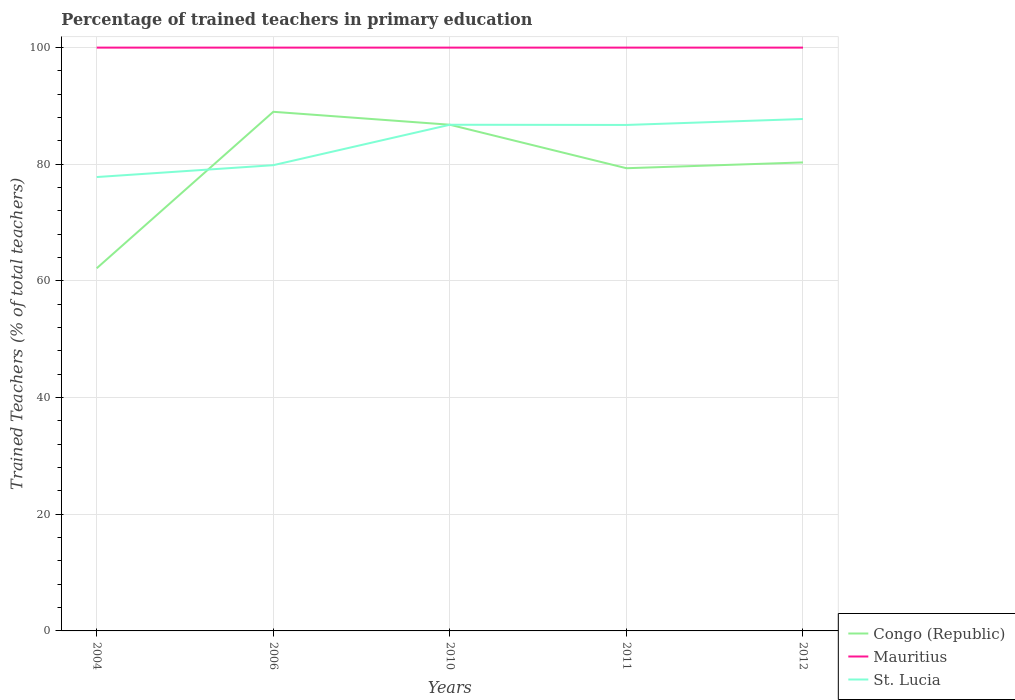How many different coloured lines are there?
Your response must be concise. 3. Does the line corresponding to St. Lucia intersect with the line corresponding to Congo (Republic)?
Keep it short and to the point. Yes. Is the number of lines equal to the number of legend labels?
Provide a succinct answer. Yes. Across all years, what is the maximum percentage of trained teachers in St. Lucia?
Provide a succinct answer. 77.81. What is the total percentage of trained teachers in Congo (Republic) in the graph?
Your answer should be very brief. -17.15. What is the difference between the highest and the second highest percentage of trained teachers in St. Lucia?
Make the answer very short. 9.95. How many lines are there?
Your answer should be compact. 3. How many years are there in the graph?
Provide a short and direct response. 5. What is the difference between two consecutive major ticks on the Y-axis?
Make the answer very short. 20. Does the graph contain any zero values?
Ensure brevity in your answer.  No. Where does the legend appear in the graph?
Make the answer very short. Bottom right. How many legend labels are there?
Your response must be concise. 3. How are the legend labels stacked?
Keep it short and to the point. Vertical. What is the title of the graph?
Provide a short and direct response. Percentage of trained teachers in primary education. What is the label or title of the X-axis?
Make the answer very short. Years. What is the label or title of the Y-axis?
Keep it short and to the point. Trained Teachers (% of total teachers). What is the Trained Teachers (% of total teachers) of Congo (Republic) in 2004?
Offer a terse response. 62.17. What is the Trained Teachers (% of total teachers) of St. Lucia in 2004?
Provide a succinct answer. 77.81. What is the Trained Teachers (% of total teachers) of Congo (Republic) in 2006?
Keep it short and to the point. 89. What is the Trained Teachers (% of total teachers) of St. Lucia in 2006?
Offer a terse response. 79.84. What is the Trained Teachers (% of total teachers) of Congo (Republic) in 2010?
Your response must be concise. 86.78. What is the Trained Teachers (% of total teachers) of St. Lucia in 2010?
Your response must be concise. 86.77. What is the Trained Teachers (% of total teachers) of Congo (Republic) in 2011?
Your answer should be very brief. 79.32. What is the Trained Teachers (% of total teachers) of St. Lucia in 2011?
Make the answer very short. 86.74. What is the Trained Teachers (% of total teachers) in Congo (Republic) in 2012?
Your answer should be very brief. 80.32. What is the Trained Teachers (% of total teachers) of Mauritius in 2012?
Provide a short and direct response. 100. What is the Trained Teachers (% of total teachers) in St. Lucia in 2012?
Give a very brief answer. 87.76. Across all years, what is the maximum Trained Teachers (% of total teachers) of Congo (Republic)?
Offer a terse response. 89. Across all years, what is the maximum Trained Teachers (% of total teachers) of Mauritius?
Provide a succinct answer. 100. Across all years, what is the maximum Trained Teachers (% of total teachers) of St. Lucia?
Your answer should be compact. 87.76. Across all years, what is the minimum Trained Teachers (% of total teachers) of Congo (Republic)?
Ensure brevity in your answer.  62.17. Across all years, what is the minimum Trained Teachers (% of total teachers) of Mauritius?
Your answer should be very brief. 100. Across all years, what is the minimum Trained Teachers (% of total teachers) of St. Lucia?
Provide a succinct answer. 77.81. What is the total Trained Teachers (% of total teachers) in Congo (Republic) in the graph?
Make the answer very short. 397.59. What is the total Trained Teachers (% of total teachers) of St. Lucia in the graph?
Offer a very short reply. 418.93. What is the difference between the Trained Teachers (% of total teachers) of Congo (Republic) in 2004 and that in 2006?
Provide a succinct answer. -26.83. What is the difference between the Trained Teachers (% of total teachers) of St. Lucia in 2004 and that in 2006?
Ensure brevity in your answer.  -2.03. What is the difference between the Trained Teachers (% of total teachers) of Congo (Republic) in 2004 and that in 2010?
Ensure brevity in your answer.  -24.61. What is the difference between the Trained Teachers (% of total teachers) in Mauritius in 2004 and that in 2010?
Ensure brevity in your answer.  0. What is the difference between the Trained Teachers (% of total teachers) of St. Lucia in 2004 and that in 2010?
Your answer should be very brief. -8.96. What is the difference between the Trained Teachers (% of total teachers) in Congo (Republic) in 2004 and that in 2011?
Provide a short and direct response. -17.15. What is the difference between the Trained Teachers (% of total teachers) in St. Lucia in 2004 and that in 2011?
Provide a short and direct response. -8.93. What is the difference between the Trained Teachers (% of total teachers) in Congo (Republic) in 2004 and that in 2012?
Keep it short and to the point. -18.15. What is the difference between the Trained Teachers (% of total teachers) in Mauritius in 2004 and that in 2012?
Provide a succinct answer. 0. What is the difference between the Trained Teachers (% of total teachers) in St. Lucia in 2004 and that in 2012?
Offer a terse response. -9.95. What is the difference between the Trained Teachers (% of total teachers) of Congo (Republic) in 2006 and that in 2010?
Offer a very short reply. 2.22. What is the difference between the Trained Teachers (% of total teachers) of Mauritius in 2006 and that in 2010?
Keep it short and to the point. 0. What is the difference between the Trained Teachers (% of total teachers) of St. Lucia in 2006 and that in 2010?
Make the answer very short. -6.93. What is the difference between the Trained Teachers (% of total teachers) of Congo (Republic) in 2006 and that in 2011?
Provide a short and direct response. 9.67. What is the difference between the Trained Teachers (% of total teachers) in St. Lucia in 2006 and that in 2011?
Offer a very short reply. -6.9. What is the difference between the Trained Teachers (% of total teachers) in Congo (Republic) in 2006 and that in 2012?
Provide a succinct answer. 8.68. What is the difference between the Trained Teachers (% of total teachers) of Mauritius in 2006 and that in 2012?
Make the answer very short. 0. What is the difference between the Trained Teachers (% of total teachers) of St. Lucia in 2006 and that in 2012?
Provide a succinct answer. -7.92. What is the difference between the Trained Teachers (% of total teachers) in Congo (Republic) in 2010 and that in 2011?
Make the answer very short. 7.45. What is the difference between the Trained Teachers (% of total teachers) in Mauritius in 2010 and that in 2011?
Give a very brief answer. 0. What is the difference between the Trained Teachers (% of total teachers) in St. Lucia in 2010 and that in 2011?
Offer a terse response. 0.03. What is the difference between the Trained Teachers (% of total teachers) in Congo (Republic) in 2010 and that in 2012?
Provide a succinct answer. 6.46. What is the difference between the Trained Teachers (% of total teachers) in Mauritius in 2010 and that in 2012?
Provide a succinct answer. 0. What is the difference between the Trained Teachers (% of total teachers) of St. Lucia in 2010 and that in 2012?
Ensure brevity in your answer.  -0.99. What is the difference between the Trained Teachers (% of total teachers) of Congo (Republic) in 2011 and that in 2012?
Offer a terse response. -0.99. What is the difference between the Trained Teachers (% of total teachers) of St. Lucia in 2011 and that in 2012?
Make the answer very short. -1.02. What is the difference between the Trained Teachers (% of total teachers) in Congo (Republic) in 2004 and the Trained Teachers (% of total teachers) in Mauritius in 2006?
Your answer should be very brief. -37.83. What is the difference between the Trained Teachers (% of total teachers) of Congo (Republic) in 2004 and the Trained Teachers (% of total teachers) of St. Lucia in 2006?
Your response must be concise. -17.67. What is the difference between the Trained Teachers (% of total teachers) in Mauritius in 2004 and the Trained Teachers (% of total teachers) in St. Lucia in 2006?
Offer a very short reply. 20.16. What is the difference between the Trained Teachers (% of total teachers) in Congo (Republic) in 2004 and the Trained Teachers (% of total teachers) in Mauritius in 2010?
Keep it short and to the point. -37.83. What is the difference between the Trained Teachers (% of total teachers) of Congo (Republic) in 2004 and the Trained Teachers (% of total teachers) of St. Lucia in 2010?
Offer a terse response. -24.6. What is the difference between the Trained Teachers (% of total teachers) in Mauritius in 2004 and the Trained Teachers (% of total teachers) in St. Lucia in 2010?
Ensure brevity in your answer.  13.23. What is the difference between the Trained Teachers (% of total teachers) of Congo (Republic) in 2004 and the Trained Teachers (% of total teachers) of Mauritius in 2011?
Keep it short and to the point. -37.83. What is the difference between the Trained Teachers (% of total teachers) in Congo (Republic) in 2004 and the Trained Teachers (% of total teachers) in St. Lucia in 2011?
Offer a terse response. -24.57. What is the difference between the Trained Teachers (% of total teachers) of Mauritius in 2004 and the Trained Teachers (% of total teachers) of St. Lucia in 2011?
Your response must be concise. 13.26. What is the difference between the Trained Teachers (% of total teachers) in Congo (Republic) in 2004 and the Trained Teachers (% of total teachers) in Mauritius in 2012?
Give a very brief answer. -37.83. What is the difference between the Trained Teachers (% of total teachers) of Congo (Republic) in 2004 and the Trained Teachers (% of total teachers) of St. Lucia in 2012?
Provide a succinct answer. -25.59. What is the difference between the Trained Teachers (% of total teachers) of Mauritius in 2004 and the Trained Teachers (% of total teachers) of St. Lucia in 2012?
Provide a succinct answer. 12.24. What is the difference between the Trained Teachers (% of total teachers) of Congo (Republic) in 2006 and the Trained Teachers (% of total teachers) of Mauritius in 2010?
Offer a very short reply. -11. What is the difference between the Trained Teachers (% of total teachers) in Congo (Republic) in 2006 and the Trained Teachers (% of total teachers) in St. Lucia in 2010?
Give a very brief answer. 2.22. What is the difference between the Trained Teachers (% of total teachers) of Mauritius in 2006 and the Trained Teachers (% of total teachers) of St. Lucia in 2010?
Provide a succinct answer. 13.23. What is the difference between the Trained Teachers (% of total teachers) in Congo (Republic) in 2006 and the Trained Teachers (% of total teachers) in Mauritius in 2011?
Your answer should be compact. -11. What is the difference between the Trained Teachers (% of total teachers) of Congo (Republic) in 2006 and the Trained Teachers (% of total teachers) of St. Lucia in 2011?
Make the answer very short. 2.26. What is the difference between the Trained Teachers (% of total teachers) of Mauritius in 2006 and the Trained Teachers (% of total teachers) of St. Lucia in 2011?
Make the answer very short. 13.26. What is the difference between the Trained Teachers (% of total teachers) of Congo (Republic) in 2006 and the Trained Teachers (% of total teachers) of Mauritius in 2012?
Make the answer very short. -11. What is the difference between the Trained Teachers (% of total teachers) in Congo (Republic) in 2006 and the Trained Teachers (% of total teachers) in St. Lucia in 2012?
Your response must be concise. 1.24. What is the difference between the Trained Teachers (% of total teachers) in Mauritius in 2006 and the Trained Teachers (% of total teachers) in St. Lucia in 2012?
Offer a very short reply. 12.24. What is the difference between the Trained Teachers (% of total teachers) of Congo (Republic) in 2010 and the Trained Teachers (% of total teachers) of Mauritius in 2011?
Ensure brevity in your answer.  -13.22. What is the difference between the Trained Teachers (% of total teachers) in Congo (Republic) in 2010 and the Trained Teachers (% of total teachers) in St. Lucia in 2011?
Give a very brief answer. 0.04. What is the difference between the Trained Teachers (% of total teachers) in Mauritius in 2010 and the Trained Teachers (% of total teachers) in St. Lucia in 2011?
Your answer should be compact. 13.26. What is the difference between the Trained Teachers (% of total teachers) in Congo (Republic) in 2010 and the Trained Teachers (% of total teachers) in Mauritius in 2012?
Offer a terse response. -13.22. What is the difference between the Trained Teachers (% of total teachers) in Congo (Republic) in 2010 and the Trained Teachers (% of total teachers) in St. Lucia in 2012?
Offer a terse response. -0.98. What is the difference between the Trained Teachers (% of total teachers) of Mauritius in 2010 and the Trained Teachers (% of total teachers) of St. Lucia in 2012?
Offer a terse response. 12.24. What is the difference between the Trained Teachers (% of total teachers) in Congo (Republic) in 2011 and the Trained Teachers (% of total teachers) in Mauritius in 2012?
Ensure brevity in your answer.  -20.68. What is the difference between the Trained Teachers (% of total teachers) in Congo (Republic) in 2011 and the Trained Teachers (% of total teachers) in St. Lucia in 2012?
Provide a succinct answer. -8.44. What is the difference between the Trained Teachers (% of total teachers) in Mauritius in 2011 and the Trained Teachers (% of total teachers) in St. Lucia in 2012?
Provide a succinct answer. 12.24. What is the average Trained Teachers (% of total teachers) in Congo (Republic) per year?
Give a very brief answer. 79.52. What is the average Trained Teachers (% of total teachers) in Mauritius per year?
Ensure brevity in your answer.  100. What is the average Trained Teachers (% of total teachers) in St. Lucia per year?
Give a very brief answer. 83.79. In the year 2004, what is the difference between the Trained Teachers (% of total teachers) in Congo (Republic) and Trained Teachers (% of total teachers) in Mauritius?
Keep it short and to the point. -37.83. In the year 2004, what is the difference between the Trained Teachers (% of total teachers) in Congo (Republic) and Trained Teachers (% of total teachers) in St. Lucia?
Offer a terse response. -15.64. In the year 2004, what is the difference between the Trained Teachers (% of total teachers) of Mauritius and Trained Teachers (% of total teachers) of St. Lucia?
Provide a succinct answer. 22.19. In the year 2006, what is the difference between the Trained Teachers (% of total teachers) in Congo (Republic) and Trained Teachers (% of total teachers) in Mauritius?
Ensure brevity in your answer.  -11. In the year 2006, what is the difference between the Trained Teachers (% of total teachers) of Congo (Republic) and Trained Teachers (% of total teachers) of St. Lucia?
Give a very brief answer. 9.15. In the year 2006, what is the difference between the Trained Teachers (% of total teachers) of Mauritius and Trained Teachers (% of total teachers) of St. Lucia?
Offer a very short reply. 20.16. In the year 2010, what is the difference between the Trained Teachers (% of total teachers) in Congo (Republic) and Trained Teachers (% of total teachers) in Mauritius?
Give a very brief answer. -13.22. In the year 2010, what is the difference between the Trained Teachers (% of total teachers) of Congo (Republic) and Trained Teachers (% of total teachers) of St. Lucia?
Provide a short and direct response. 0. In the year 2010, what is the difference between the Trained Teachers (% of total teachers) in Mauritius and Trained Teachers (% of total teachers) in St. Lucia?
Offer a terse response. 13.23. In the year 2011, what is the difference between the Trained Teachers (% of total teachers) in Congo (Republic) and Trained Teachers (% of total teachers) in Mauritius?
Ensure brevity in your answer.  -20.68. In the year 2011, what is the difference between the Trained Teachers (% of total teachers) in Congo (Republic) and Trained Teachers (% of total teachers) in St. Lucia?
Provide a short and direct response. -7.42. In the year 2011, what is the difference between the Trained Teachers (% of total teachers) of Mauritius and Trained Teachers (% of total teachers) of St. Lucia?
Keep it short and to the point. 13.26. In the year 2012, what is the difference between the Trained Teachers (% of total teachers) in Congo (Republic) and Trained Teachers (% of total teachers) in Mauritius?
Offer a very short reply. -19.68. In the year 2012, what is the difference between the Trained Teachers (% of total teachers) of Congo (Republic) and Trained Teachers (% of total teachers) of St. Lucia?
Make the answer very short. -7.44. In the year 2012, what is the difference between the Trained Teachers (% of total teachers) in Mauritius and Trained Teachers (% of total teachers) in St. Lucia?
Offer a terse response. 12.24. What is the ratio of the Trained Teachers (% of total teachers) in Congo (Republic) in 2004 to that in 2006?
Your answer should be very brief. 0.7. What is the ratio of the Trained Teachers (% of total teachers) in St. Lucia in 2004 to that in 2006?
Give a very brief answer. 0.97. What is the ratio of the Trained Teachers (% of total teachers) in Congo (Republic) in 2004 to that in 2010?
Keep it short and to the point. 0.72. What is the ratio of the Trained Teachers (% of total teachers) of Mauritius in 2004 to that in 2010?
Your answer should be very brief. 1. What is the ratio of the Trained Teachers (% of total teachers) in St. Lucia in 2004 to that in 2010?
Your response must be concise. 0.9. What is the ratio of the Trained Teachers (% of total teachers) of Congo (Republic) in 2004 to that in 2011?
Your answer should be very brief. 0.78. What is the ratio of the Trained Teachers (% of total teachers) in St. Lucia in 2004 to that in 2011?
Give a very brief answer. 0.9. What is the ratio of the Trained Teachers (% of total teachers) in Congo (Republic) in 2004 to that in 2012?
Make the answer very short. 0.77. What is the ratio of the Trained Teachers (% of total teachers) in St. Lucia in 2004 to that in 2012?
Give a very brief answer. 0.89. What is the ratio of the Trained Teachers (% of total teachers) of Congo (Republic) in 2006 to that in 2010?
Your answer should be very brief. 1.03. What is the ratio of the Trained Teachers (% of total teachers) of Mauritius in 2006 to that in 2010?
Offer a terse response. 1. What is the ratio of the Trained Teachers (% of total teachers) in St. Lucia in 2006 to that in 2010?
Keep it short and to the point. 0.92. What is the ratio of the Trained Teachers (% of total teachers) in Congo (Republic) in 2006 to that in 2011?
Make the answer very short. 1.12. What is the ratio of the Trained Teachers (% of total teachers) of Mauritius in 2006 to that in 2011?
Give a very brief answer. 1. What is the ratio of the Trained Teachers (% of total teachers) of St. Lucia in 2006 to that in 2011?
Give a very brief answer. 0.92. What is the ratio of the Trained Teachers (% of total teachers) in Congo (Republic) in 2006 to that in 2012?
Keep it short and to the point. 1.11. What is the ratio of the Trained Teachers (% of total teachers) in Mauritius in 2006 to that in 2012?
Your answer should be very brief. 1. What is the ratio of the Trained Teachers (% of total teachers) of St. Lucia in 2006 to that in 2012?
Offer a very short reply. 0.91. What is the ratio of the Trained Teachers (% of total teachers) of Congo (Republic) in 2010 to that in 2011?
Your answer should be very brief. 1.09. What is the ratio of the Trained Teachers (% of total teachers) of Mauritius in 2010 to that in 2011?
Offer a terse response. 1. What is the ratio of the Trained Teachers (% of total teachers) of St. Lucia in 2010 to that in 2011?
Your answer should be compact. 1. What is the ratio of the Trained Teachers (% of total teachers) in Congo (Republic) in 2010 to that in 2012?
Offer a terse response. 1.08. What is the ratio of the Trained Teachers (% of total teachers) of Congo (Republic) in 2011 to that in 2012?
Give a very brief answer. 0.99. What is the ratio of the Trained Teachers (% of total teachers) in St. Lucia in 2011 to that in 2012?
Provide a succinct answer. 0.99. What is the difference between the highest and the second highest Trained Teachers (% of total teachers) in Congo (Republic)?
Your answer should be compact. 2.22. What is the difference between the highest and the second highest Trained Teachers (% of total teachers) of St. Lucia?
Give a very brief answer. 0.99. What is the difference between the highest and the lowest Trained Teachers (% of total teachers) of Congo (Republic)?
Make the answer very short. 26.83. What is the difference between the highest and the lowest Trained Teachers (% of total teachers) in St. Lucia?
Your response must be concise. 9.95. 